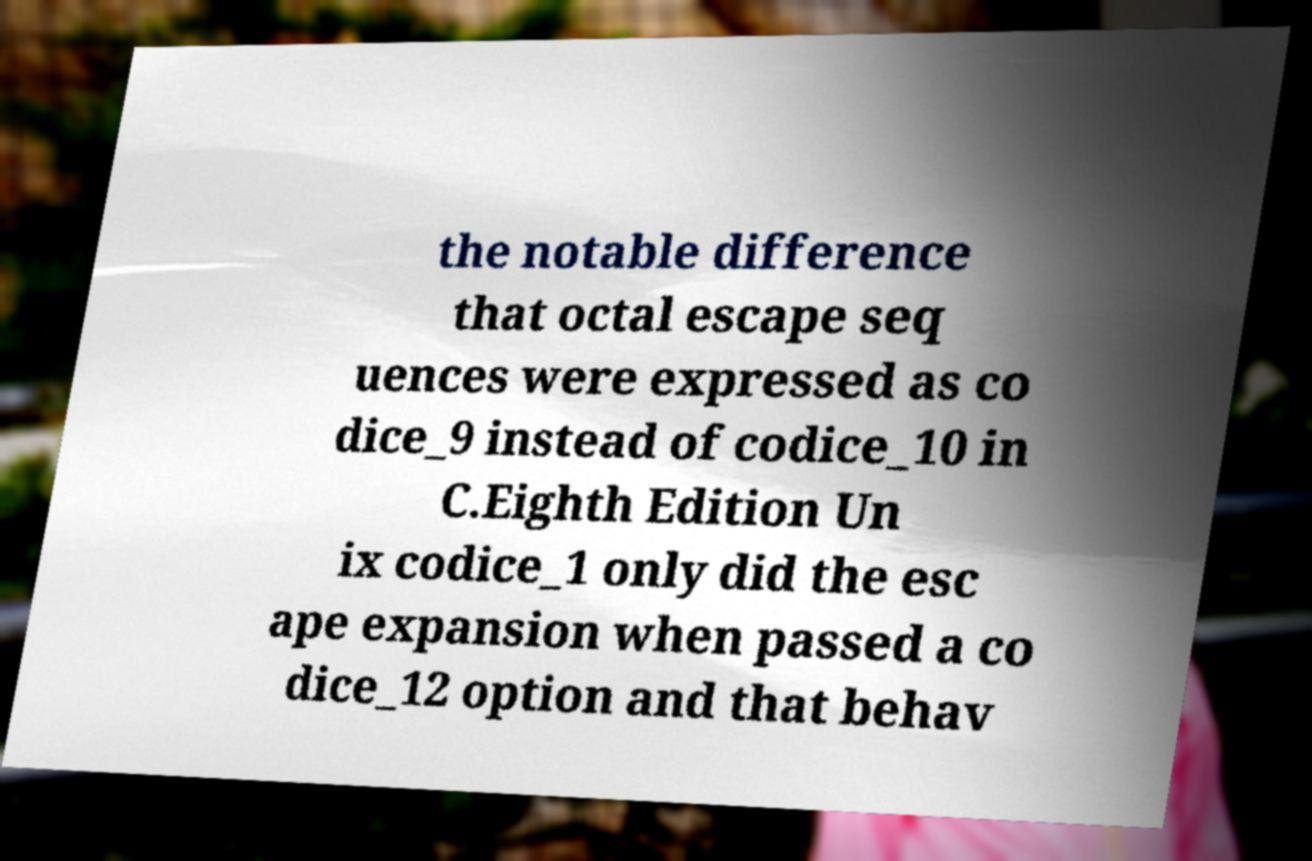Please read and relay the text visible in this image. What does it say? the notable difference that octal escape seq uences were expressed as co dice_9 instead of codice_10 in C.Eighth Edition Un ix codice_1 only did the esc ape expansion when passed a co dice_12 option and that behav 